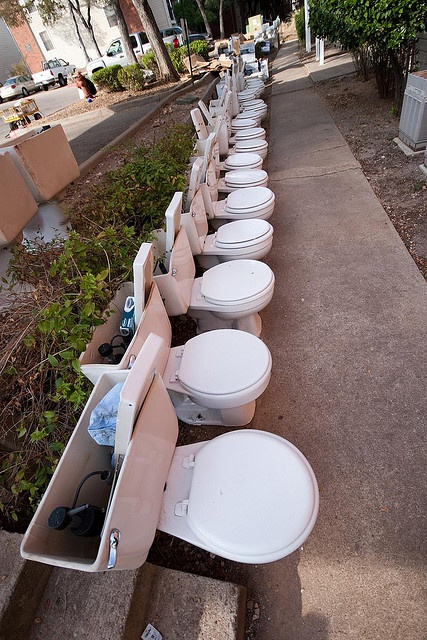Describe the objects in this image and their specific colors. I can see toilet in gray, lavender, darkgray, and black tones, toilet in gray, lavender, and darkgray tones, toilet in gray, lavender, and darkgray tones, toilet in gray, lavender, and darkgray tones, and toilet in gray, lavender, and darkgray tones in this image. 